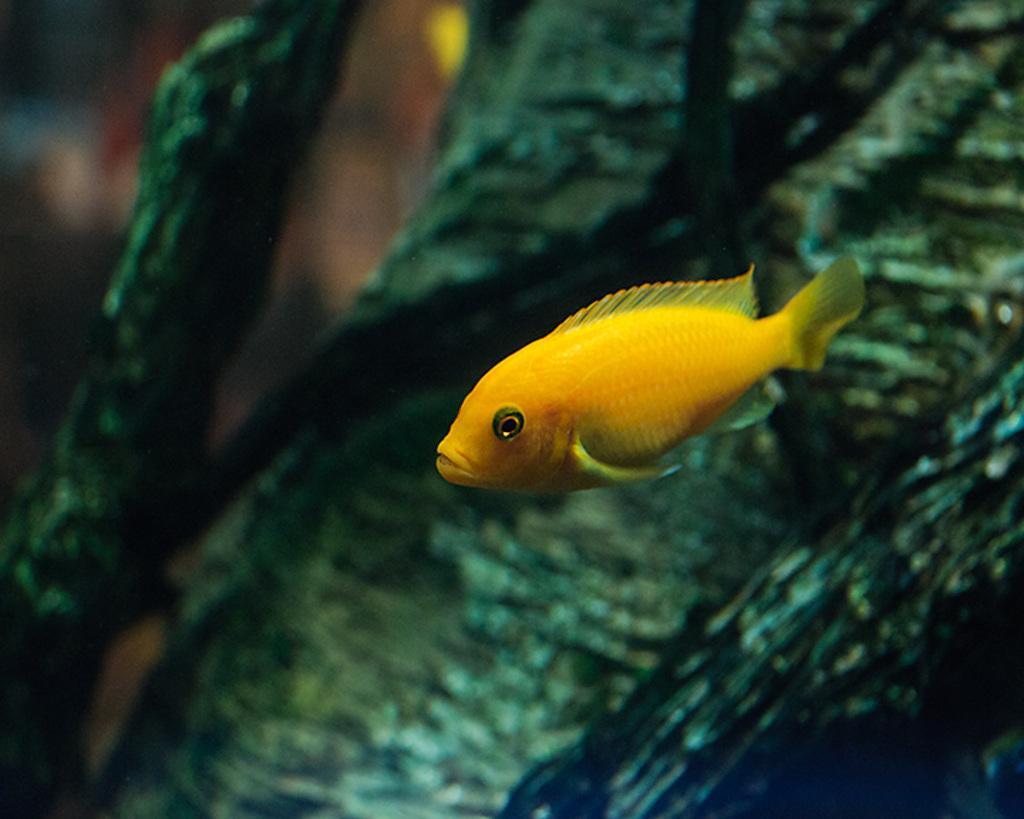Describe this image in one or two sentences. In this picture we can see a fish in water and in the background it is blurry. 